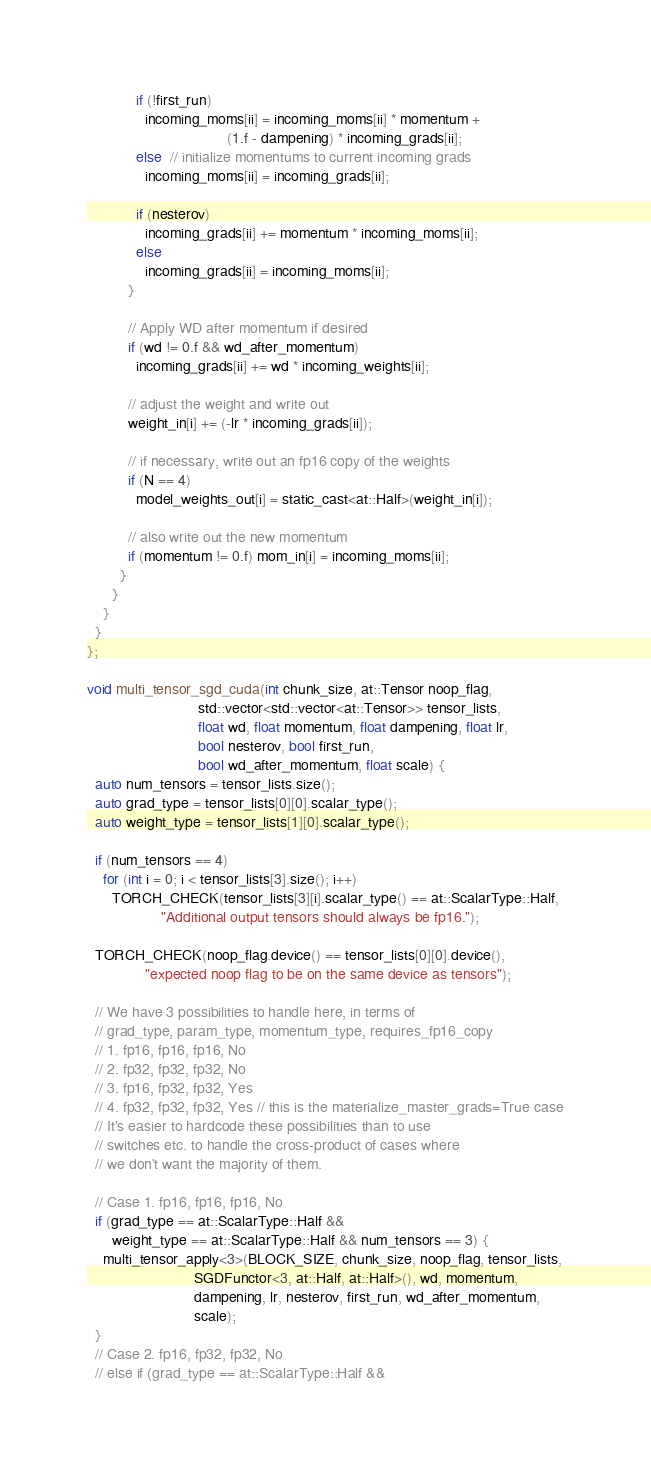<code> <loc_0><loc_0><loc_500><loc_500><_Cuda_>            if (!first_run)
              incoming_moms[ii] = incoming_moms[ii] * momentum +
                                  (1.f - dampening) * incoming_grads[ii];
            else  // initialize momentums to current incoming grads
              incoming_moms[ii] = incoming_grads[ii];

            if (nesterov)
              incoming_grads[ii] += momentum * incoming_moms[ii];
            else
              incoming_grads[ii] = incoming_moms[ii];
          }

          // Apply WD after momentum if desired
          if (wd != 0.f && wd_after_momentum)
            incoming_grads[ii] += wd * incoming_weights[ii];

          // adjust the weight and write out
          weight_in[i] += (-lr * incoming_grads[ii]);

          // if necessary, write out an fp16 copy of the weights
          if (N == 4)
            model_weights_out[i] = static_cast<at::Half>(weight_in[i]);

          // also write out the new momentum
          if (momentum != 0.f) mom_in[i] = incoming_moms[ii];
        }
      }
    }
  }
};

void multi_tensor_sgd_cuda(int chunk_size, at::Tensor noop_flag,
                           std::vector<std::vector<at::Tensor>> tensor_lists,
                           float wd, float momentum, float dampening, float lr,
                           bool nesterov, bool first_run,
                           bool wd_after_momentum, float scale) {
  auto num_tensors = tensor_lists.size();
  auto grad_type = tensor_lists[0][0].scalar_type();
  auto weight_type = tensor_lists[1][0].scalar_type();

  if (num_tensors == 4)
    for (int i = 0; i < tensor_lists[3].size(); i++)
      TORCH_CHECK(tensor_lists[3][i].scalar_type() == at::ScalarType::Half,
                  "Additional output tensors should always be fp16.");

  TORCH_CHECK(noop_flag.device() == tensor_lists[0][0].device(),
              "expected noop flag to be on the same device as tensors");

  // We have 3 possibilities to handle here, in terms of
  // grad_type, param_type, momentum_type, requires_fp16_copy
  // 1. fp16, fp16, fp16, No
  // 2. fp32, fp32, fp32, No
  // 3. fp16, fp32, fp32, Yes
  // 4. fp32, fp32, fp32, Yes // this is the materialize_master_grads=True case
  // It's easier to hardcode these possibilities than to use
  // switches etc. to handle the cross-product of cases where
  // we don't want the majority of them.

  // Case 1. fp16, fp16, fp16, No
  if (grad_type == at::ScalarType::Half &&
      weight_type == at::ScalarType::Half && num_tensors == 3) {
    multi_tensor_apply<3>(BLOCK_SIZE, chunk_size, noop_flag, tensor_lists,
                          SGDFunctor<3, at::Half, at::Half>(), wd, momentum,
                          dampening, lr, nesterov, first_run, wd_after_momentum,
                          scale);
  }
  // Case 2. fp16, fp32, fp32, No
  // else if (grad_type == at::ScalarType::Half &&</code> 